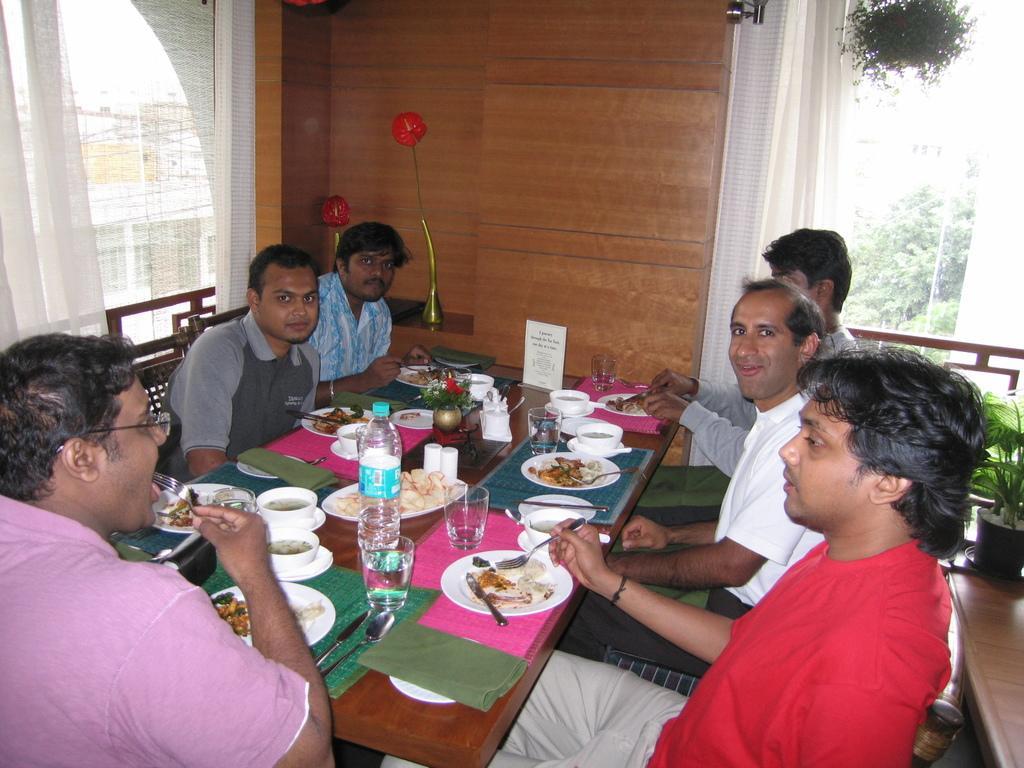Could you give a brief overview of what you see in this image? In this image, group of people are sat on the chair. In the middle, we can see wooden dining table. So many items are placed on it. Few are eating the food. And back side, we can see wooden wall. On right side, few plants and fencing, white color curtain, tree. Left side, we can see white color curtain in building. 